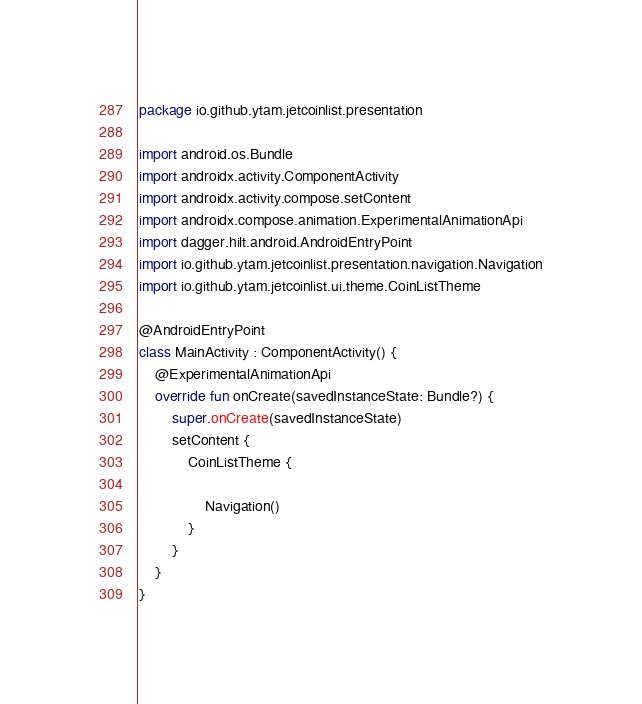<code> <loc_0><loc_0><loc_500><loc_500><_Kotlin_>package io.github.ytam.jetcoinlist.presentation

import android.os.Bundle
import androidx.activity.ComponentActivity
import androidx.activity.compose.setContent
import androidx.compose.animation.ExperimentalAnimationApi
import dagger.hilt.android.AndroidEntryPoint
import io.github.ytam.jetcoinlist.presentation.navigation.Navigation
import io.github.ytam.jetcoinlist.ui.theme.CoinListTheme

@AndroidEntryPoint
class MainActivity : ComponentActivity() {
    @ExperimentalAnimationApi
    override fun onCreate(savedInstanceState: Bundle?) {
        super.onCreate(savedInstanceState)
        setContent {
            CoinListTheme {

                Navigation()
            }
        }
    }
}
</code> 